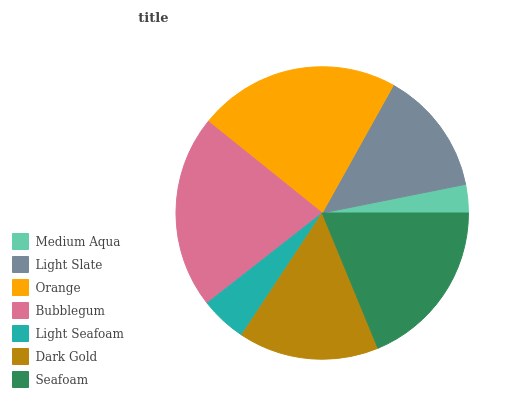Is Medium Aqua the minimum?
Answer yes or no. Yes. Is Orange the maximum?
Answer yes or no. Yes. Is Light Slate the minimum?
Answer yes or no. No. Is Light Slate the maximum?
Answer yes or no. No. Is Light Slate greater than Medium Aqua?
Answer yes or no. Yes. Is Medium Aqua less than Light Slate?
Answer yes or no. Yes. Is Medium Aqua greater than Light Slate?
Answer yes or no. No. Is Light Slate less than Medium Aqua?
Answer yes or no. No. Is Dark Gold the high median?
Answer yes or no. Yes. Is Dark Gold the low median?
Answer yes or no. Yes. Is Orange the high median?
Answer yes or no. No. Is Seafoam the low median?
Answer yes or no. No. 